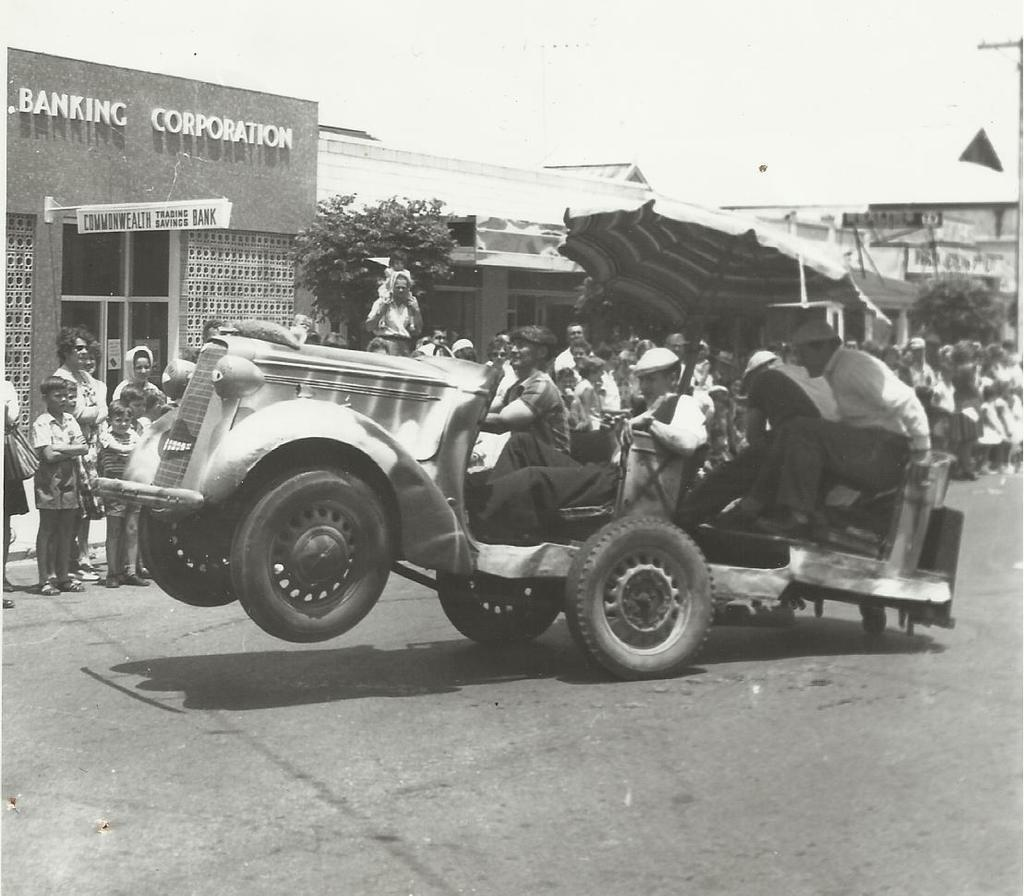What is happening in the image involving a vehicle? There are people riding in a vehicle on the road. What can be seen in the background of the image? There are buildings and trees in the background of the image. Are there any people visible in the background? Yes, there are people visible in the background of the image. What type of bike can be seen in the mouth of the person in the image? There is no bike or person with a bike in their mouth present in the image. 